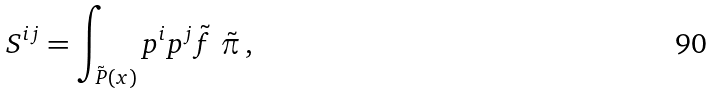Convert formula to latex. <formula><loc_0><loc_0><loc_500><loc_500>S ^ { i j } = \int _ { \tilde { P } ( x ) } p ^ { i } p ^ { j } \tilde { f } \ \tilde { \pi } \, ,</formula> 